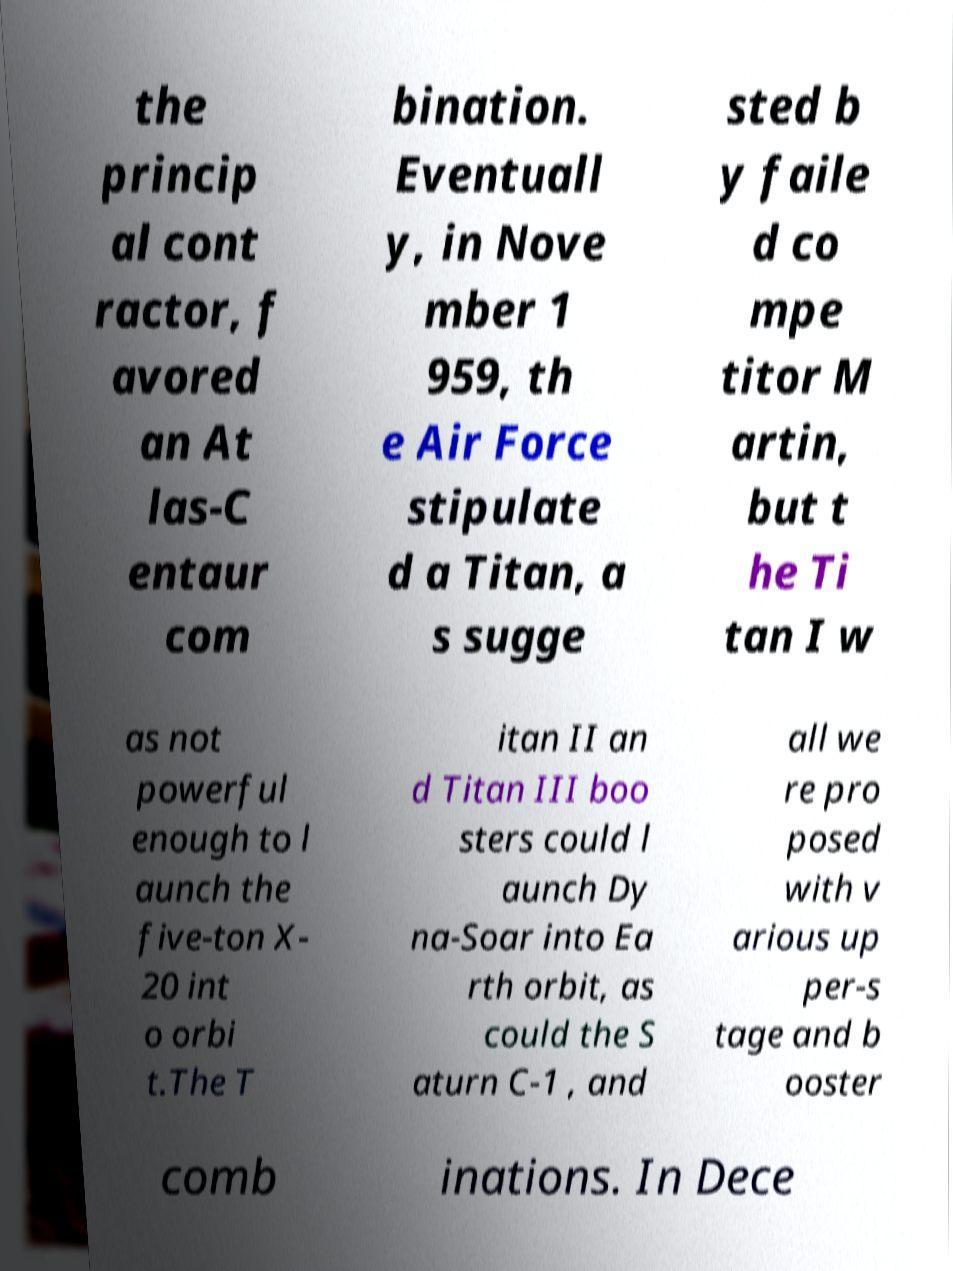Please identify and transcribe the text found in this image. the princip al cont ractor, f avored an At las-C entaur com bination. Eventuall y, in Nove mber 1 959, th e Air Force stipulate d a Titan, a s sugge sted b y faile d co mpe titor M artin, but t he Ti tan I w as not powerful enough to l aunch the five-ton X- 20 int o orbi t.The T itan II an d Titan III boo sters could l aunch Dy na-Soar into Ea rth orbit, as could the S aturn C-1 , and all we re pro posed with v arious up per-s tage and b ooster comb inations. In Dece 